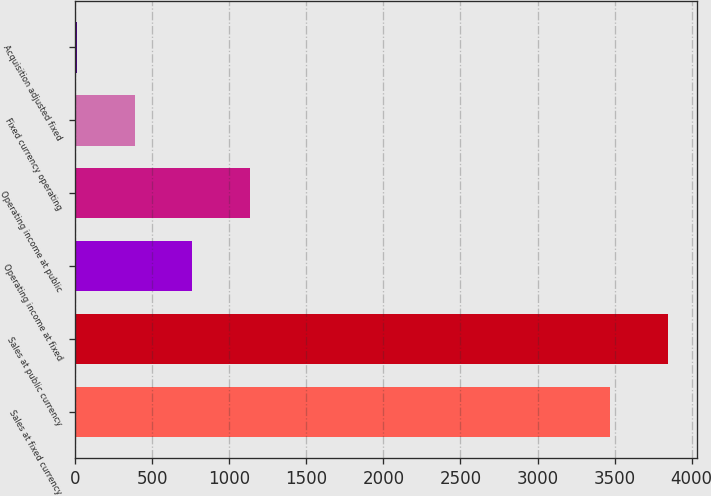Convert chart to OTSL. <chart><loc_0><loc_0><loc_500><loc_500><bar_chart><fcel>Sales at fixed currency<fcel>Sales at public currency<fcel>Operating income at fixed<fcel>Operating income at public<fcel>Fixed currency operating<fcel>Acquisition adjusted fixed<nl><fcel>3470.8<fcel>3844.2<fcel>760<fcel>1133.4<fcel>386.6<fcel>13.2<nl></chart> 